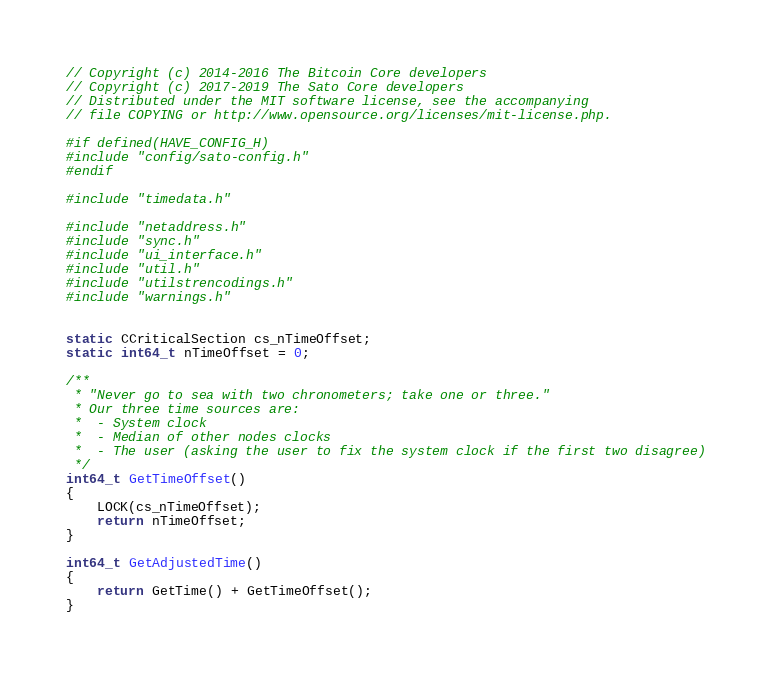Convert code to text. <code><loc_0><loc_0><loc_500><loc_500><_C++_>// Copyright (c) 2014-2016 The Bitcoin Core developers
// Copyright (c) 2017-2019 The Sato Core developers
// Distributed under the MIT software license, see the accompanying
// file COPYING or http://www.opensource.org/licenses/mit-license.php.

#if defined(HAVE_CONFIG_H)
#include "config/sato-config.h"
#endif

#include "timedata.h"

#include "netaddress.h"
#include "sync.h"
#include "ui_interface.h"
#include "util.h"
#include "utilstrencodings.h"
#include "warnings.h"


static CCriticalSection cs_nTimeOffset;
static int64_t nTimeOffset = 0;

/**
 * "Never go to sea with two chronometers; take one or three."
 * Our three time sources are:
 *  - System clock
 *  - Median of other nodes clocks
 *  - The user (asking the user to fix the system clock if the first two disagree)
 */
int64_t GetTimeOffset()
{
    LOCK(cs_nTimeOffset);
    return nTimeOffset;
}

int64_t GetAdjustedTime()
{
    return GetTime() + GetTimeOffset();
}
</code> 